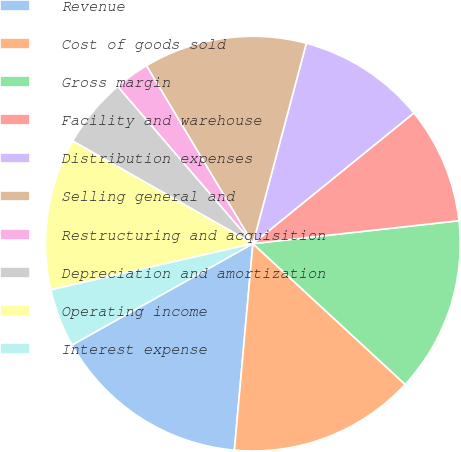<chart> <loc_0><loc_0><loc_500><loc_500><pie_chart><fcel>Revenue<fcel>Cost of goods sold<fcel>Gross margin<fcel>Facility and warehouse<fcel>Distribution expenses<fcel>Selling general and<fcel>Restructuring and acquisition<fcel>Depreciation and amortization<fcel>Operating income<fcel>Interest expense<nl><fcel>15.45%<fcel>14.55%<fcel>13.64%<fcel>9.09%<fcel>10.0%<fcel>12.73%<fcel>2.73%<fcel>5.45%<fcel>11.82%<fcel>4.55%<nl></chart> 